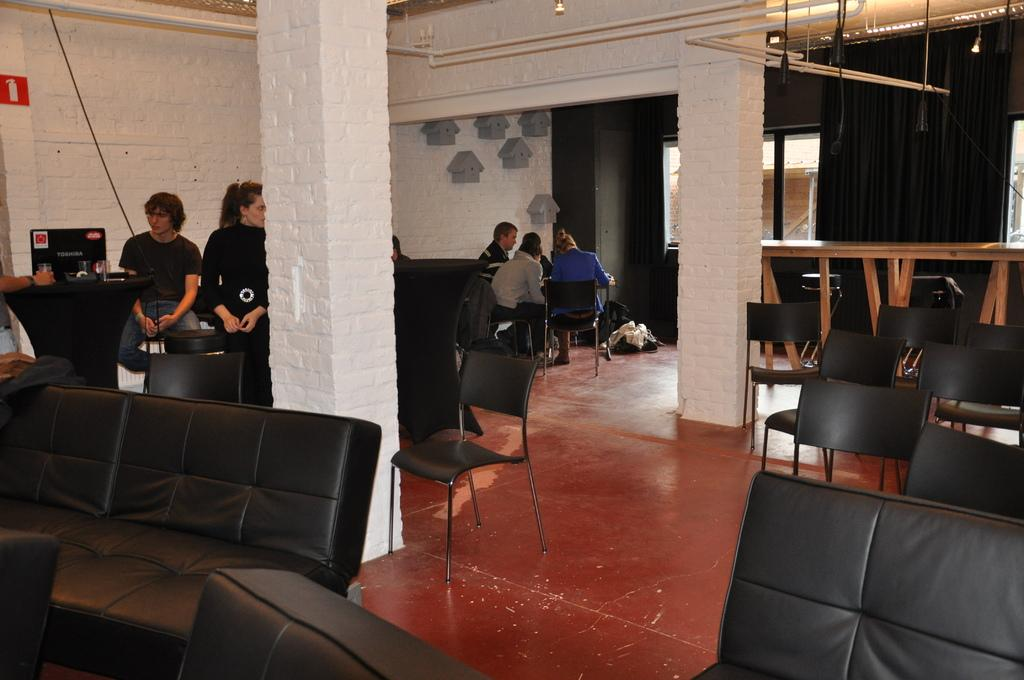Where are the people located in the image? The people are sitting on the left side of the image. What furniture can be seen in the middle of the image? There are sofas and chairs in the middle of the image. What else can be seen in the middle of the image besides furniture? There are people in the middle of the image. What architectural feature is present in the middle of the image? There is a pillar in the middle of the image. What is the floor like in the middle of the image? There is a floor in the middle of the image. What can be seen in the background of the image? There is a wall, a window, and a light in the background of the image. How many crackers are on the table in the image? There is no table or crackers present in the image. What type of beggar is visible in the image? There is no beggar present in the image. 